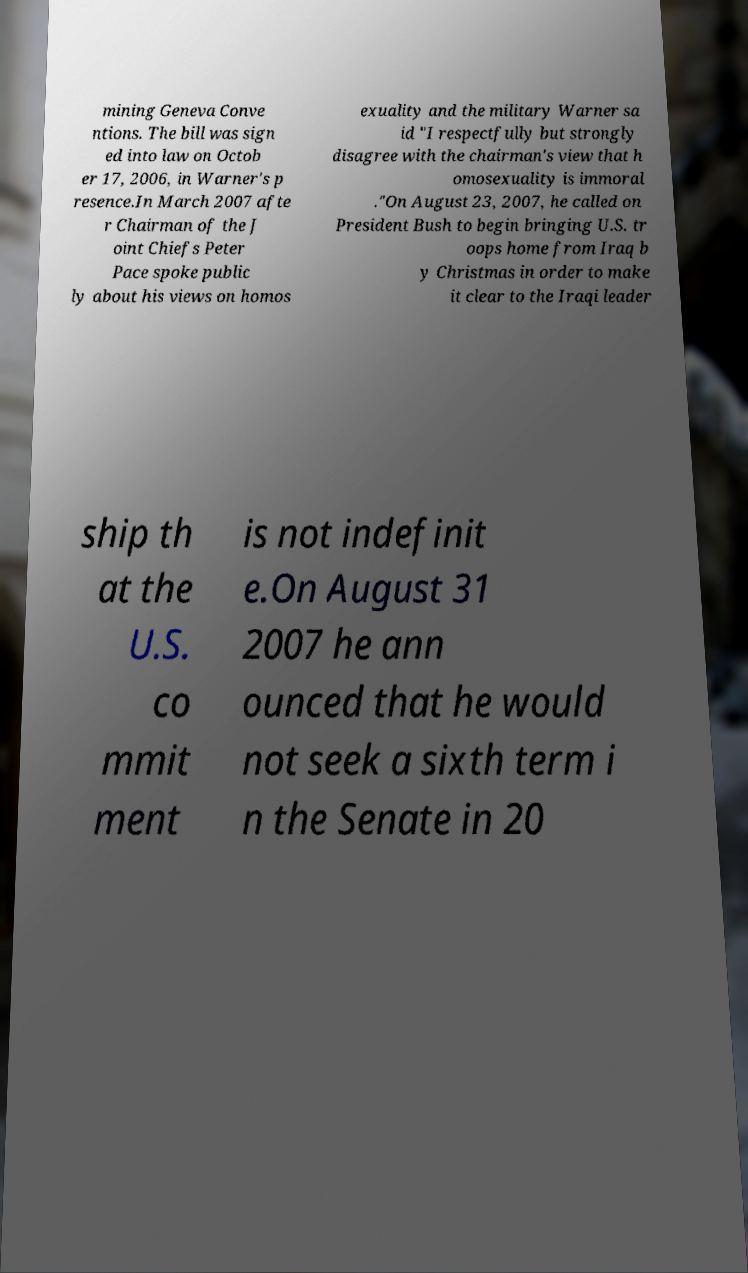For documentation purposes, I need the text within this image transcribed. Could you provide that? mining Geneva Conve ntions. The bill was sign ed into law on Octob er 17, 2006, in Warner's p resence.In March 2007 afte r Chairman of the J oint Chiefs Peter Pace spoke public ly about his views on homos exuality and the military Warner sa id "I respectfully but strongly disagree with the chairman's view that h omosexuality is immoral ."On August 23, 2007, he called on President Bush to begin bringing U.S. tr oops home from Iraq b y Christmas in order to make it clear to the Iraqi leader ship th at the U.S. co mmit ment is not indefinit e.On August 31 2007 he ann ounced that he would not seek a sixth term i n the Senate in 20 